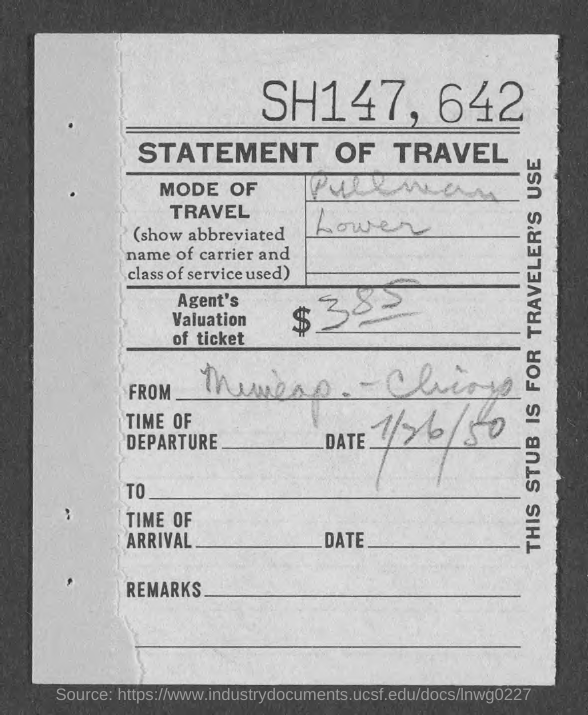What is the Title of the document?
Your answer should be compact. STATEMENT OF TRAVEL. What is the Agent's valuation of ticket?
Offer a very short reply. $385. 